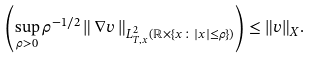Convert formula to latex. <formula><loc_0><loc_0><loc_500><loc_500>\left ( \sup _ { \rho > 0 } \rho ^ { - 1 / 2 } \left \| \, \nabla v \, \right \| _ { L _ { T , x } ^ { 2 } ( \mathbb { R } \times \{ x \colon | x | \leq \rho \} ) } \right ) \leq \| v \| _ { X } .</formula> 